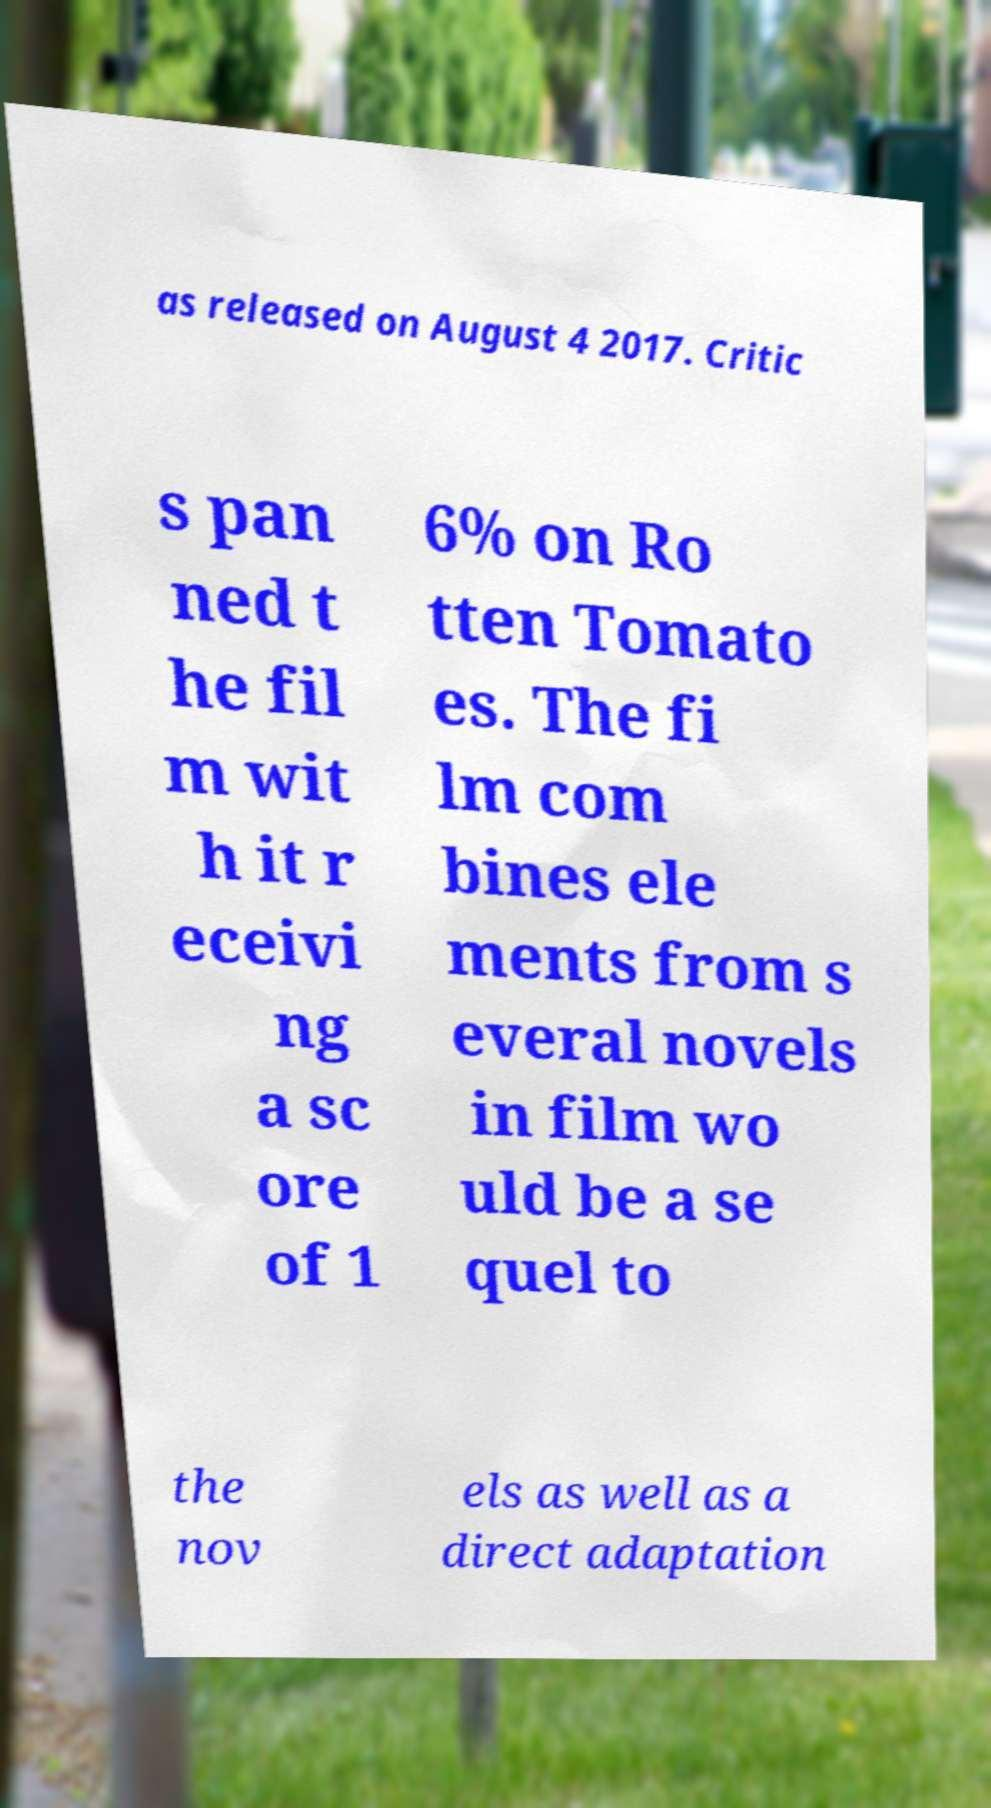Please identify and transcribe the text found in this image. as released on August 4 2017. Critic s pan ned t he fil m wit h it r eceivi ng a sc ore of 1 6% on Ro tten Tomato es. The fi lm com bines ele ments from s everal novels in film wo uld be a se quel to the nov els as well as a direct adaptation 